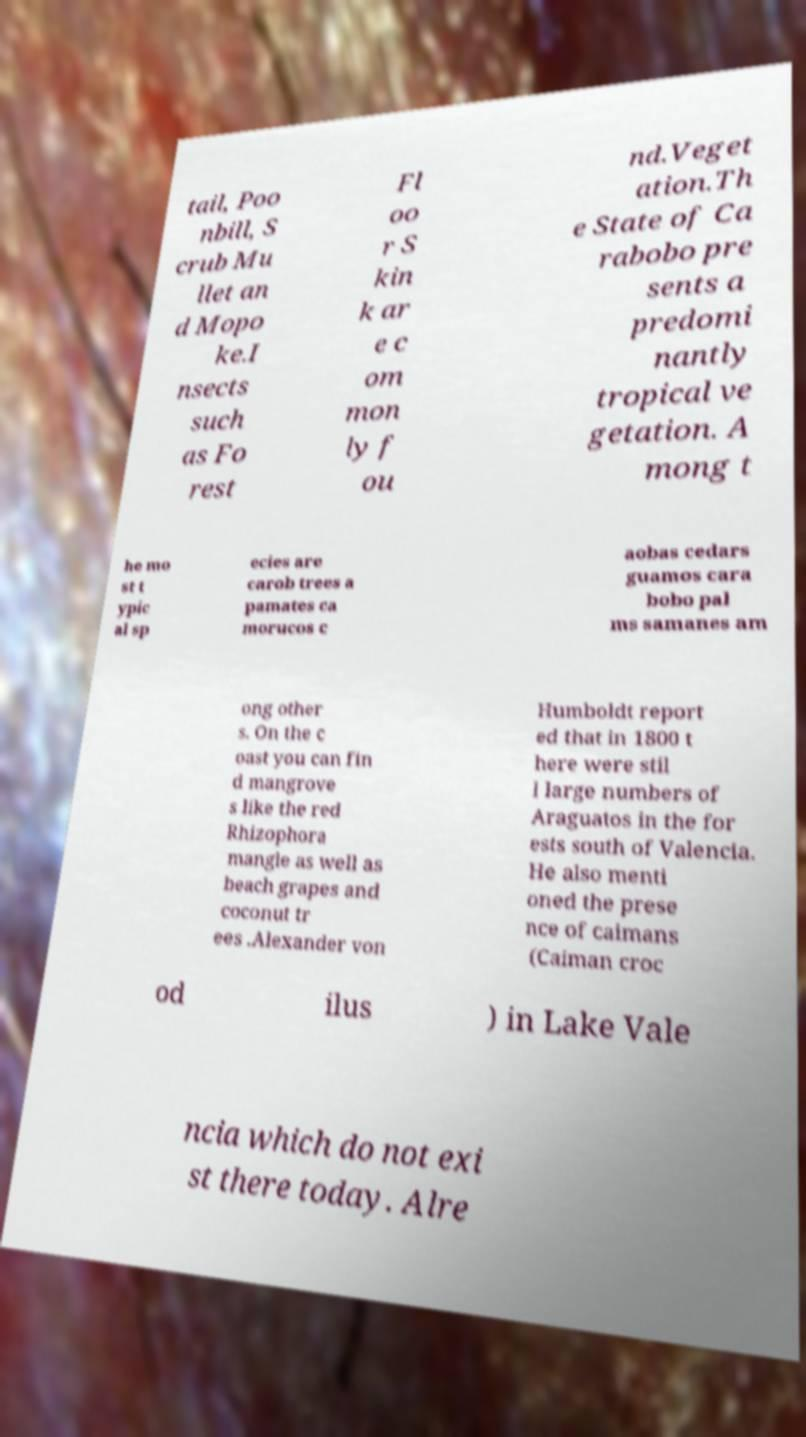Can you accurately transcribe the text from the provided image for me? tail, Poo nbill, S crub Mu llet an d Mopo ke.I nsects such as Fo rest Fl oo r S kin k ar e c om mon ly f ou nd.Veget ation.Th e State of Ca rabobo pre sents a predomi nantly tropical ve getation. A mong t he mo st t ypic al sp ecies are carob trees a pamates ca morucos c aobas cedars guamos cara bobo pal ms samanes am ong other s. On the c oast you can fin d mangrove s like the red Rhizophora mangle as well as beach grapes and coconut tr ees .Alexander von Humboldt report ed that in 1800 t here were stil l large numbers of Araguatos in the for ests south of Valencia. He also menti oned the prese nce of caimans (Caiman croc od ilus ) in Lake Vale ncia which do not exi st there today. Alre 